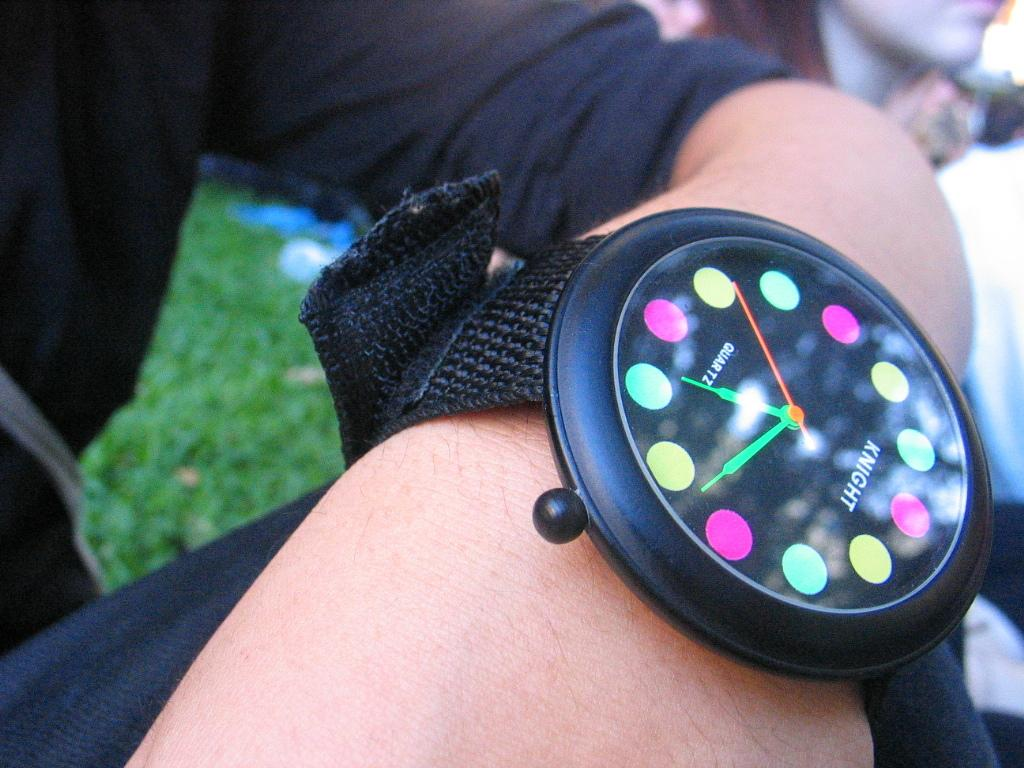<image>
Render a clear and concise summary of the photo. A person wearing a black Knight brand watch. 